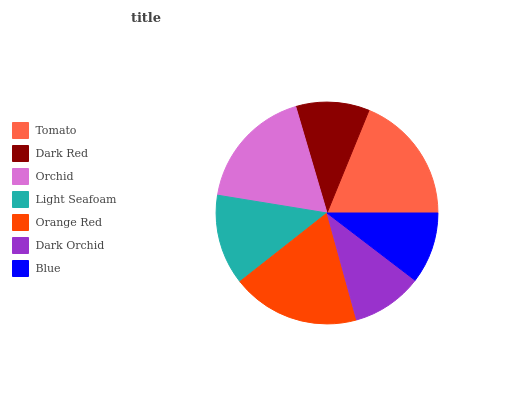Is Dark Orchid the minimum?
Answer yes or no. Yes. Is Tomato the maximum?
Answer yes or no. Yes. Is Dark Red the minimum?
Answer yes or no. No. Is Dark Red the maximum?
Answer yes or no. No. Is Tomato greater than Dark Red?
Answer yes or no. Yes. Is Dark Red less than Tomato?
Answer yes or no. Yes. Is Dark Red greater than Tomato?
Answer yes or no. No. Is Tomato less than Dark Red?
Answer yes or no. No. Is Light Seafoam the high median?
Answer yes or no. Yes. Is Light Seafoam the low median?
Answer yes or no. Yes. Is Orchid the high median?
Answer yes or no. No. Is Dark Red the low median?
Answer yes or no. No. 